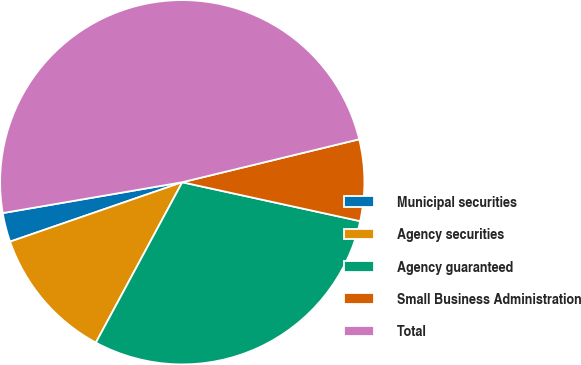Convert chart to OTSL. <chart><loc_0><loc_0><loc_500><loc_500><pie_chart><fcel>Municipal securities<fcel>Agency securities<fcel>Agency guaranteed<fcel>Small Business Administration<fcel>Total<nl><fcel>2.58%<fcel>11.85%<fcel>29.44%<fcel>7.22%<fcel>48.92%<nl></chart> 